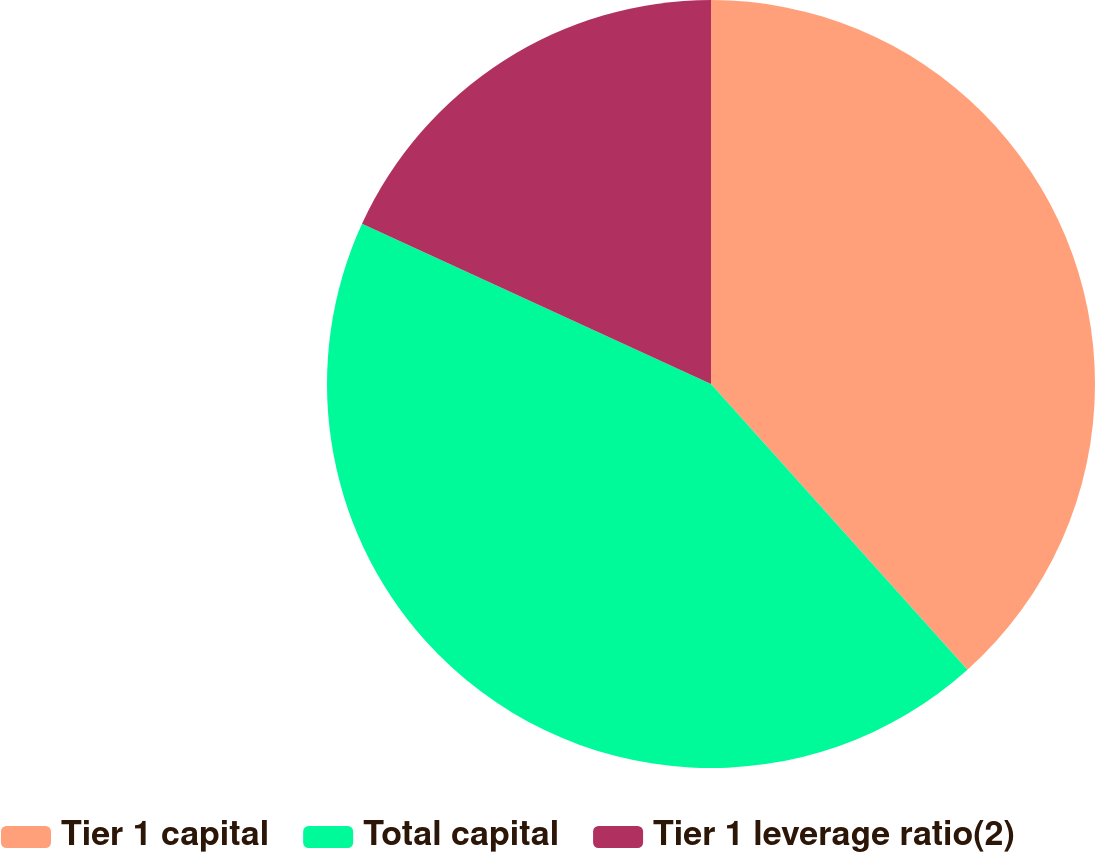Convert chart. <chart><loc_0><loc_0><loc_500><loc_500><pie_chart><fcel>Tier 1 capital<fcel>Total capital<fcel>Tier 1 leverage ratio(2)<nl><fcel>38.36%<fcel>43.49%<fcel>18.15%<nl></chart> 